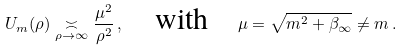Convert formula to latex. <formula><loc_0><loc_0><loc_500><loc_500>U _ { m } ( \rho ) \underset { \rho \to \infty } { \asymp } \frac { \mu ^ { 2 } } { \rho ^ { 2 } } \, , \quad \text {with} \quad \mu = \sqrt { m ^ { 2 } + \beta _ { \infty } } \neq m \, .</formula> 